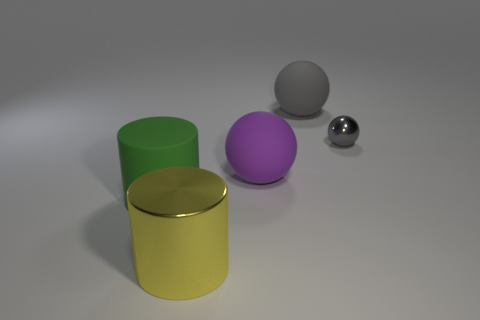There is a big object that is the same color as the small sphere; what material is it?
Offer a very short reply. Rubber. There is a metallic thing right of the yellow thing; is it the same shape as the large thing in front of the green object?
Provide a short and direct response. No. What is the shape of the big rubber object that is the same color as the tiny thing?
Keep it short and to the point. Sphere. How many large things have the same material as the tiny ball?
Offer a very short reply. 1. What shape is the large thing that is both on the right side of the big green cylinder and left of the purple thing?
Give a very brief answer. Cylinder. Is the material of the large sphere that is on the right side of the purple rubber ball the same as the large yellow object?
Your response must be concise. No. What is the color of the other cylinder that is the same size as the yellow cylinder?
Ensure brevity in your answer.  Green. Is there a thing of the same color as the metal sphere?
Your response must be concise. Yes. What size is the purple sphere that is made of the same material as the green cylinder?
Make the answer very short. Large. What size is the matte object that is the same color as the small shiny sphere?
Offer a very short reply. Large. 